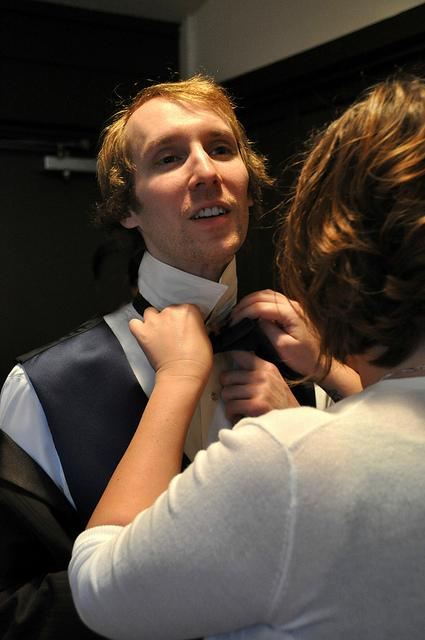What is the woman adjusting? tie 